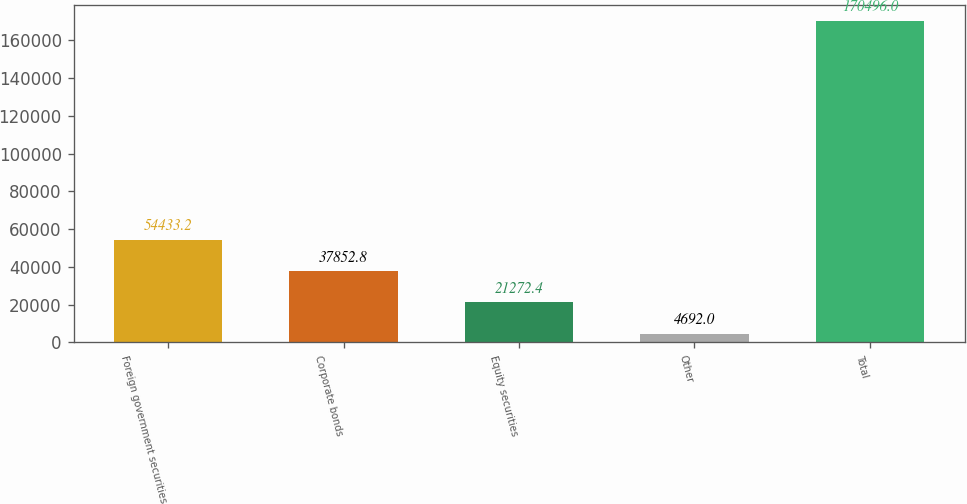Convert chart. <chart><loc_0><loc_0><loc_500><loc_500><bar_chart><fcel>Foreign government securities<fcel>Corporate bonds<fcel>Equity securities<fcel>Other<fcel>Total<nl><fcel>54433.2<fcel>37852.8<fcel>21272.4<fcel>4692<fcel>170496<nl></chart> 